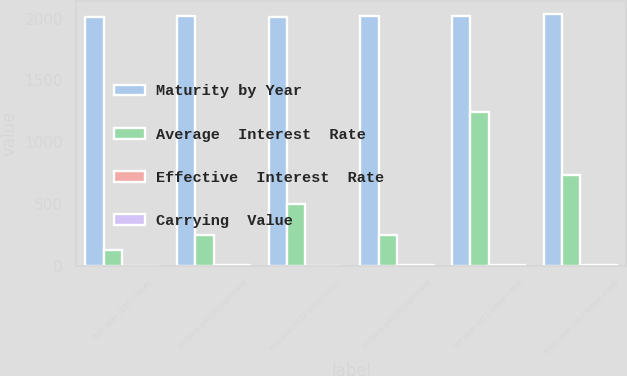Convert chart to OTSL. <chart><loc_0><loc_0><loc_500><loc_500><stacked_bar_chart><ecel><fcel>Term loan (125 million)<fcel>Series B private placement<fcel>Five year 2012 senior notes<fcel>Series A private placement<fcel>Ten year 2011 senior notes<fcel>Thirty year 2011 senior notes<nl><fcel>Maturity by Year<fcel>2016<fcel>2023<fcel>2017<fcel>2018<fcel>2021<fcel>2041<nl><fcel>Average  Interest  Rate<fcel>125<fcel>249.1<fcel>497.9<fcel>248.6<fcel>1243.7<fcel>738.3<nl><fcel>Effective  Interest  Rate<fcel>1.4<fcel>4.32<fcel>1.45<fcel>3.69<fcel>4.35<fcel>5.5<nl><fcel>Carrying  Value<fcel>1.4<fcel>4.36<fcel>0.82<fcel>4.32<fcel>4.43<fcel>5.56<nl></chart> 